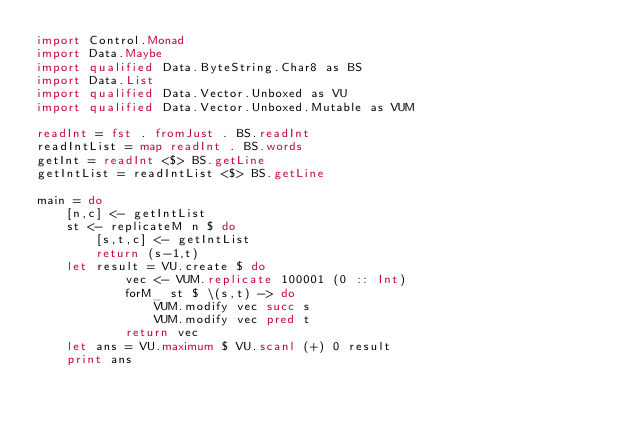<code> <loc_0><loc_0><loc_500><loc_500><_Haskell_>import Control.Monad
import Data.Maybe
import qualified Data.ByteString.Char8 as BS
import Data.List
import qualified Data.Vector.Unboxed as VU
import qualified Data.Vector.Unboxed.Mutable as VUM

readInt = fst . fromJust . BS.readInt
readIntList = map readInt . BS.words
getInt = readInt <$> BS.getLine
getIntList = readIntList <$> BS.getLine

main = do
    [n,c] <- getIntList
    st <- replicateM n $ do
        [s,t,c] <- getIntList
        return (s-1,t)
    let result = VU.create $ do
            vec <- VUM.replicate 100001 (0 :: Int)
            forM_ st $ \(s,t) -> do
                VUM.modify vec succ s
                VUM.modify vec pred t
            return vec
    let ans = VU.maximum $ VU.scanl (+) 0 result
    print ans</code> 